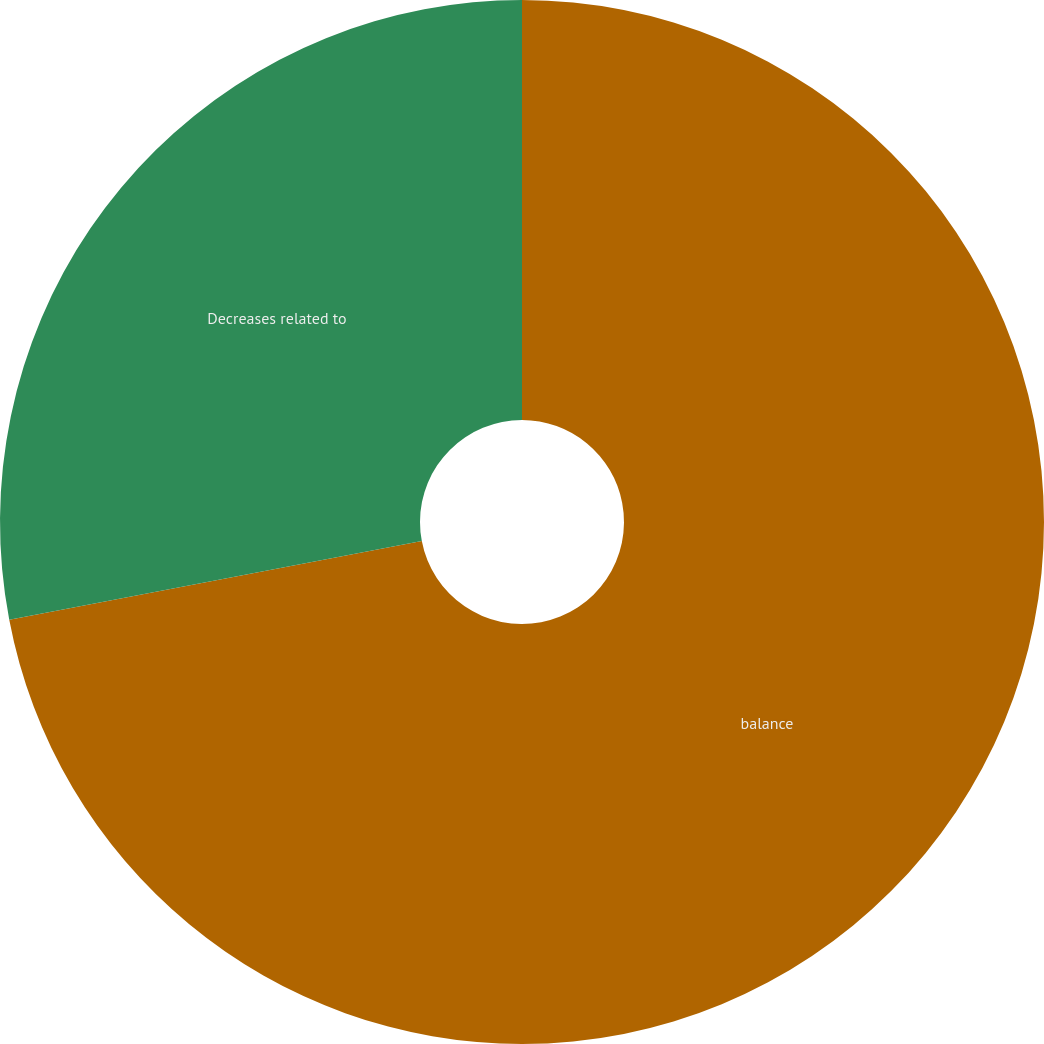Convert chart. <chart><loc_0><loc_0><loc_500><loc_500><pie_chart><fcel>balance<fcel>Decreases related to<nl><fcel>72.0%<fcel>28.0%<nl></chart> 